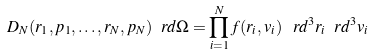Convert formula to latex. <formula><loc_0><loc_0><loc_500><loc_500>D _ { N } ( r _ { 1 } , p _ { 1 } , \dots , r _ { N } , p _ { N } ) \ r d \Omega = \prod _ { i = 1 } ^ { N } f ( r _ { i } , v _ { i } ) \, \ r d ^ { 3 } r _ { i } \ r d ^ { 3 } v _ { i }</formula> 